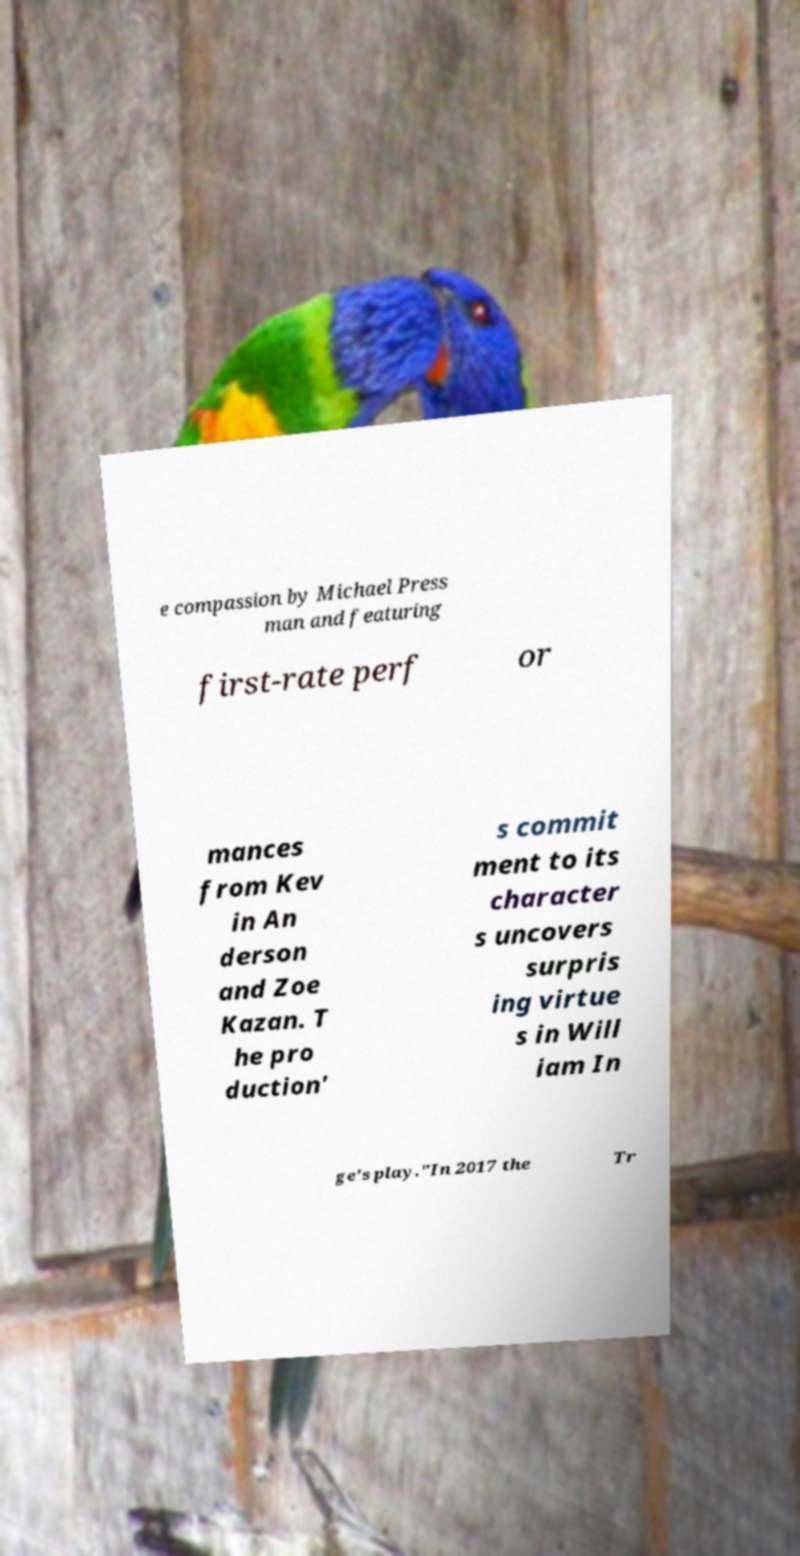For documentation purposes, I need the text within this image transcribed. Could you provide that? e compassion by Michael Press man and featuring first-rate perf or mances from Kev in An derson and Zoe Kazan. T he pro duction' s commit ment to its character s uncovers surpris ing virtue s in Will iam In ge's play."In 2017 the Tr 